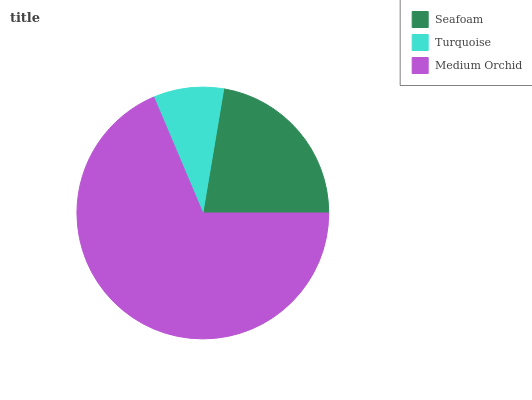Is Turquoise the minimum?
Answer yes or no. Yes. Is Medium Orchid the maximum?
Answer yes or no. Yes. Is Medium Orchid the minimum?
Answer yes or no. No. Is Turquoise the maximum?
Answer yes or no. No. Is Medium Orchid greater than Turquoise?
Answer yes or no. Yes. Is Turquoise less than Medium Orchid?
Answer yes or no. Yes. Is Turquoise greater than Medium Orchid?
Answer yes or no. No. Is Medium Orchid less than Turquoise?
Answer yes or no. No. Is Seafoam the high median?
Answer yes or no. Yes. Is Seafoam the low median?
Answer yes or no. Yes. Is Turquoise the high median?
Answer yes or no. No. Is Turquoise the low median?
Answer yes or no. No. 